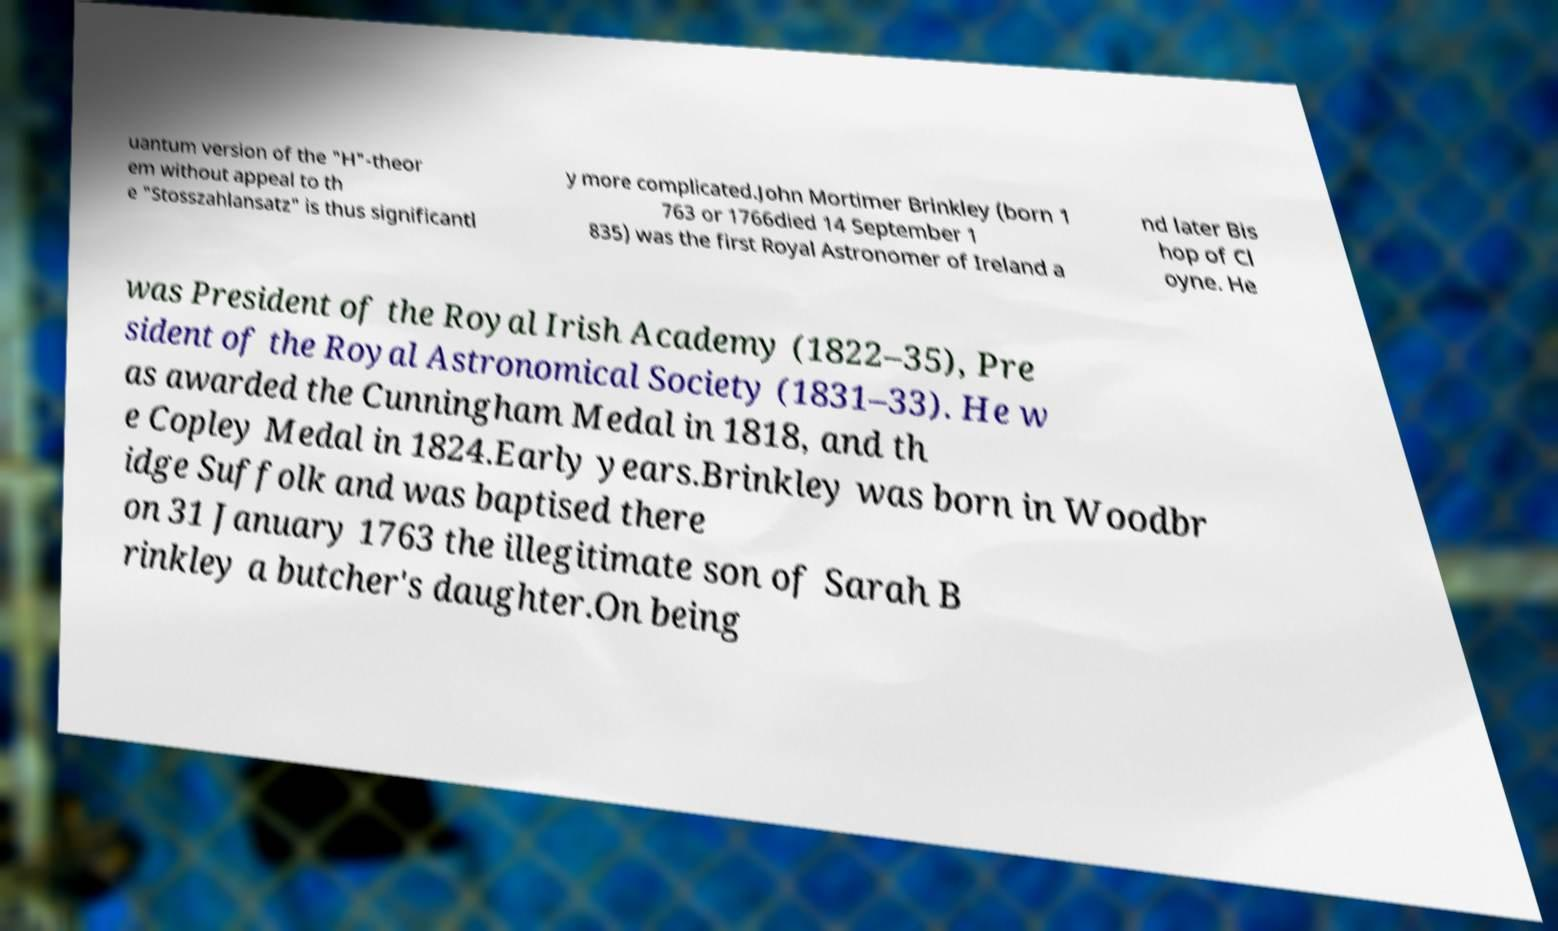Can you read and provide the text displayed in the image?This photo seems to have some interesting text. Can you extract and type it out for me? uantum version of the "H"-theor em without appeal to th e "Stosszahlansatz" is thus significantl y more complicated.John Mortimer Brinkley (born 1 763 or 1766died 14 September 1 835) was the first Royal Astronomer of Ireland a nd later Bis hop of Cl oyne. He was President of the Royal Irish Academy (1822–35), Pre sident of the Royal Astronomical Society (1831–33). He w as awarded the Cunningham Medal in 1818, and th e Copley Medal in 1824.Early years.Brinkley was born in Woodbr idge Suffolk and was baptised there on 31 January 1763 the illegitimate son of Sarah B rinkley a butcher's daughter.On being 